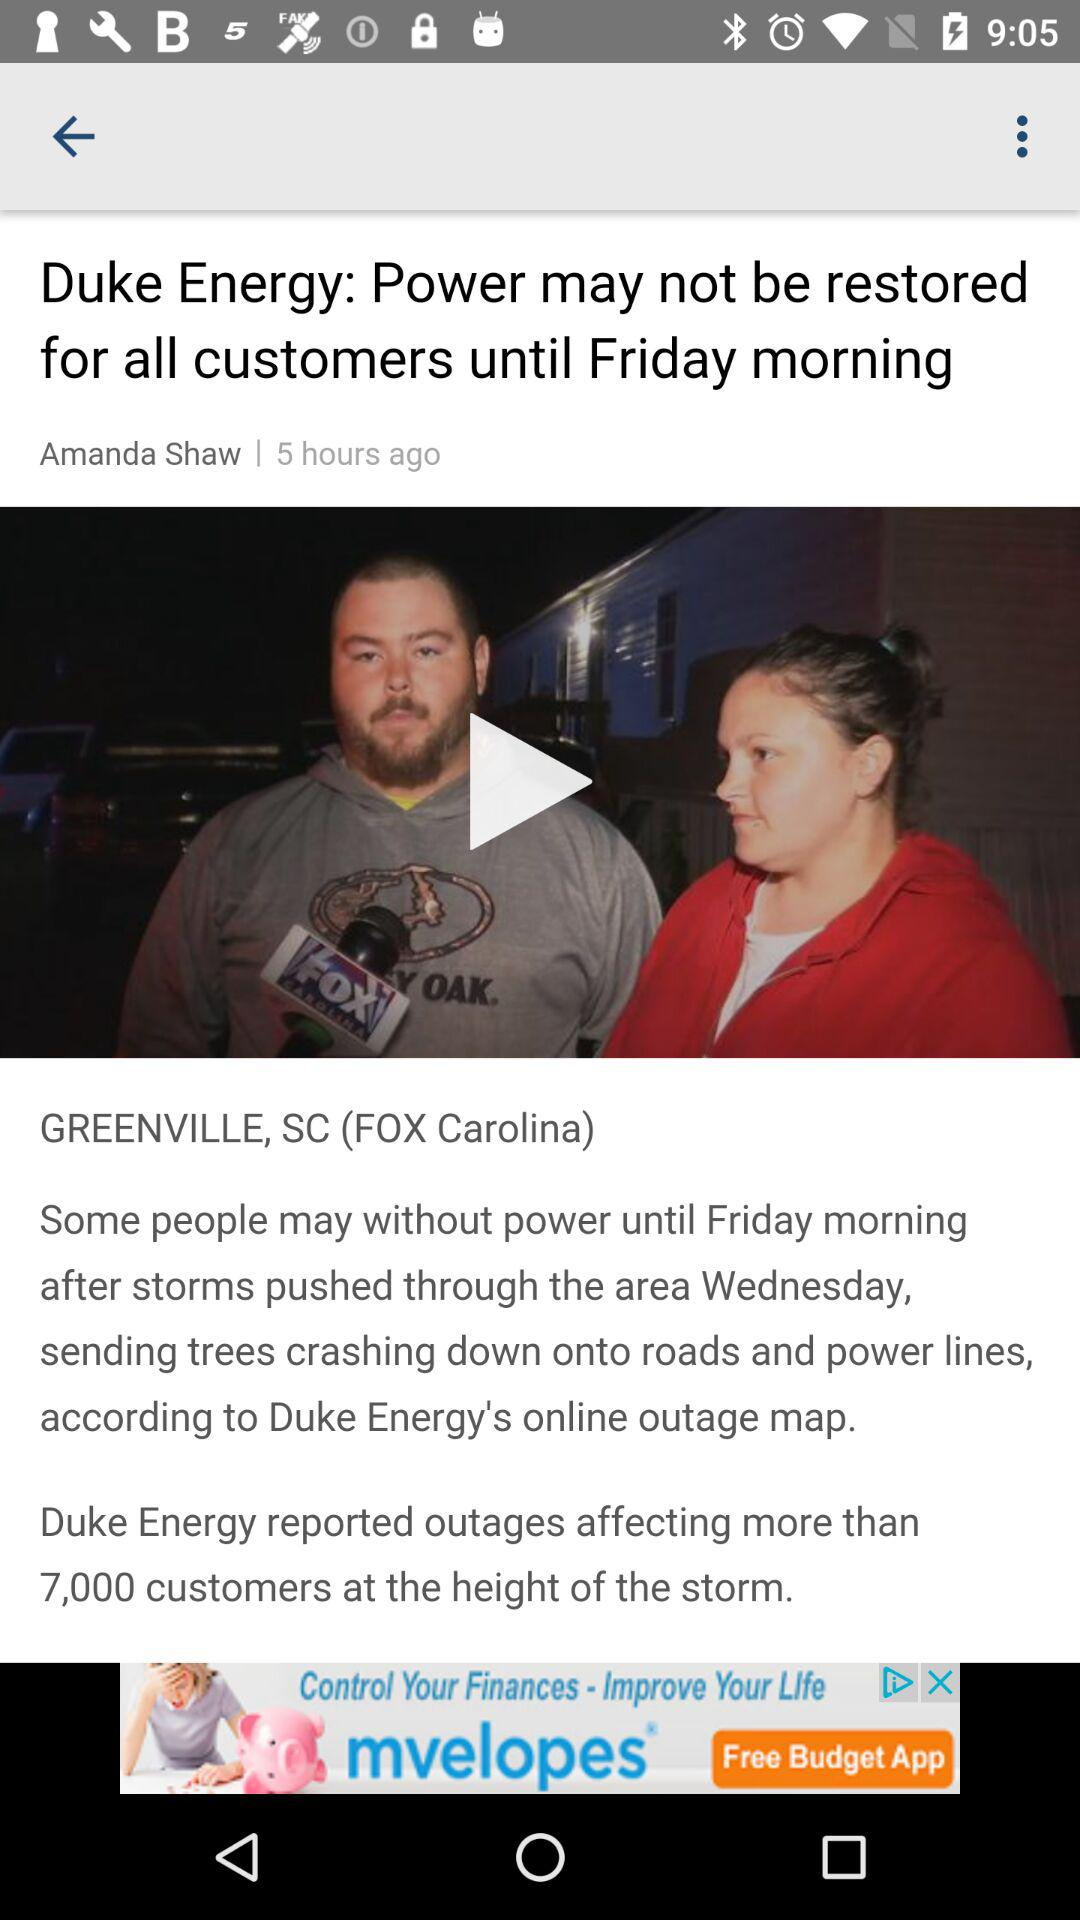What is the shown location? The shown location is Greenville, SC. 